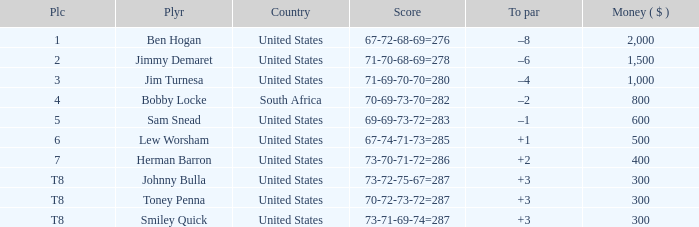What is the Score of the game of the Player in Place 4? 70-69-73-70=282. 